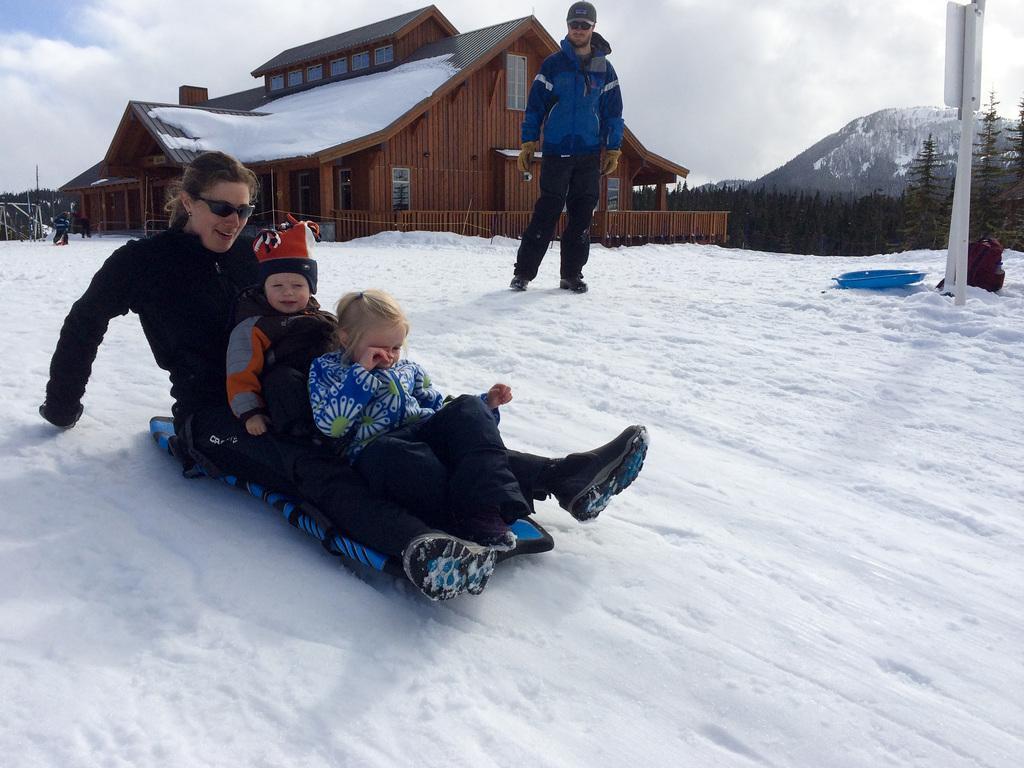Can you describe this image briefly? Here in this picture we can see a woman with couple of children sitting on a board and sledding on the mountain, that is fully covered with snow and we can see all of them are wearing jackets and gloves and the woman is wearing goggles and they are smiling and behind them we can see a person standing and he is also wearing jacket, gloves, goggles and cap on him and behind them we can see a house present and we can also see snow on it and in the far we can see fencing present and we can also see plants and trees present and in the far we can see other mountains that are covered with snow and we can see the sky is fully covered with clouds and on the right side we can see a sign board present on a pole. 